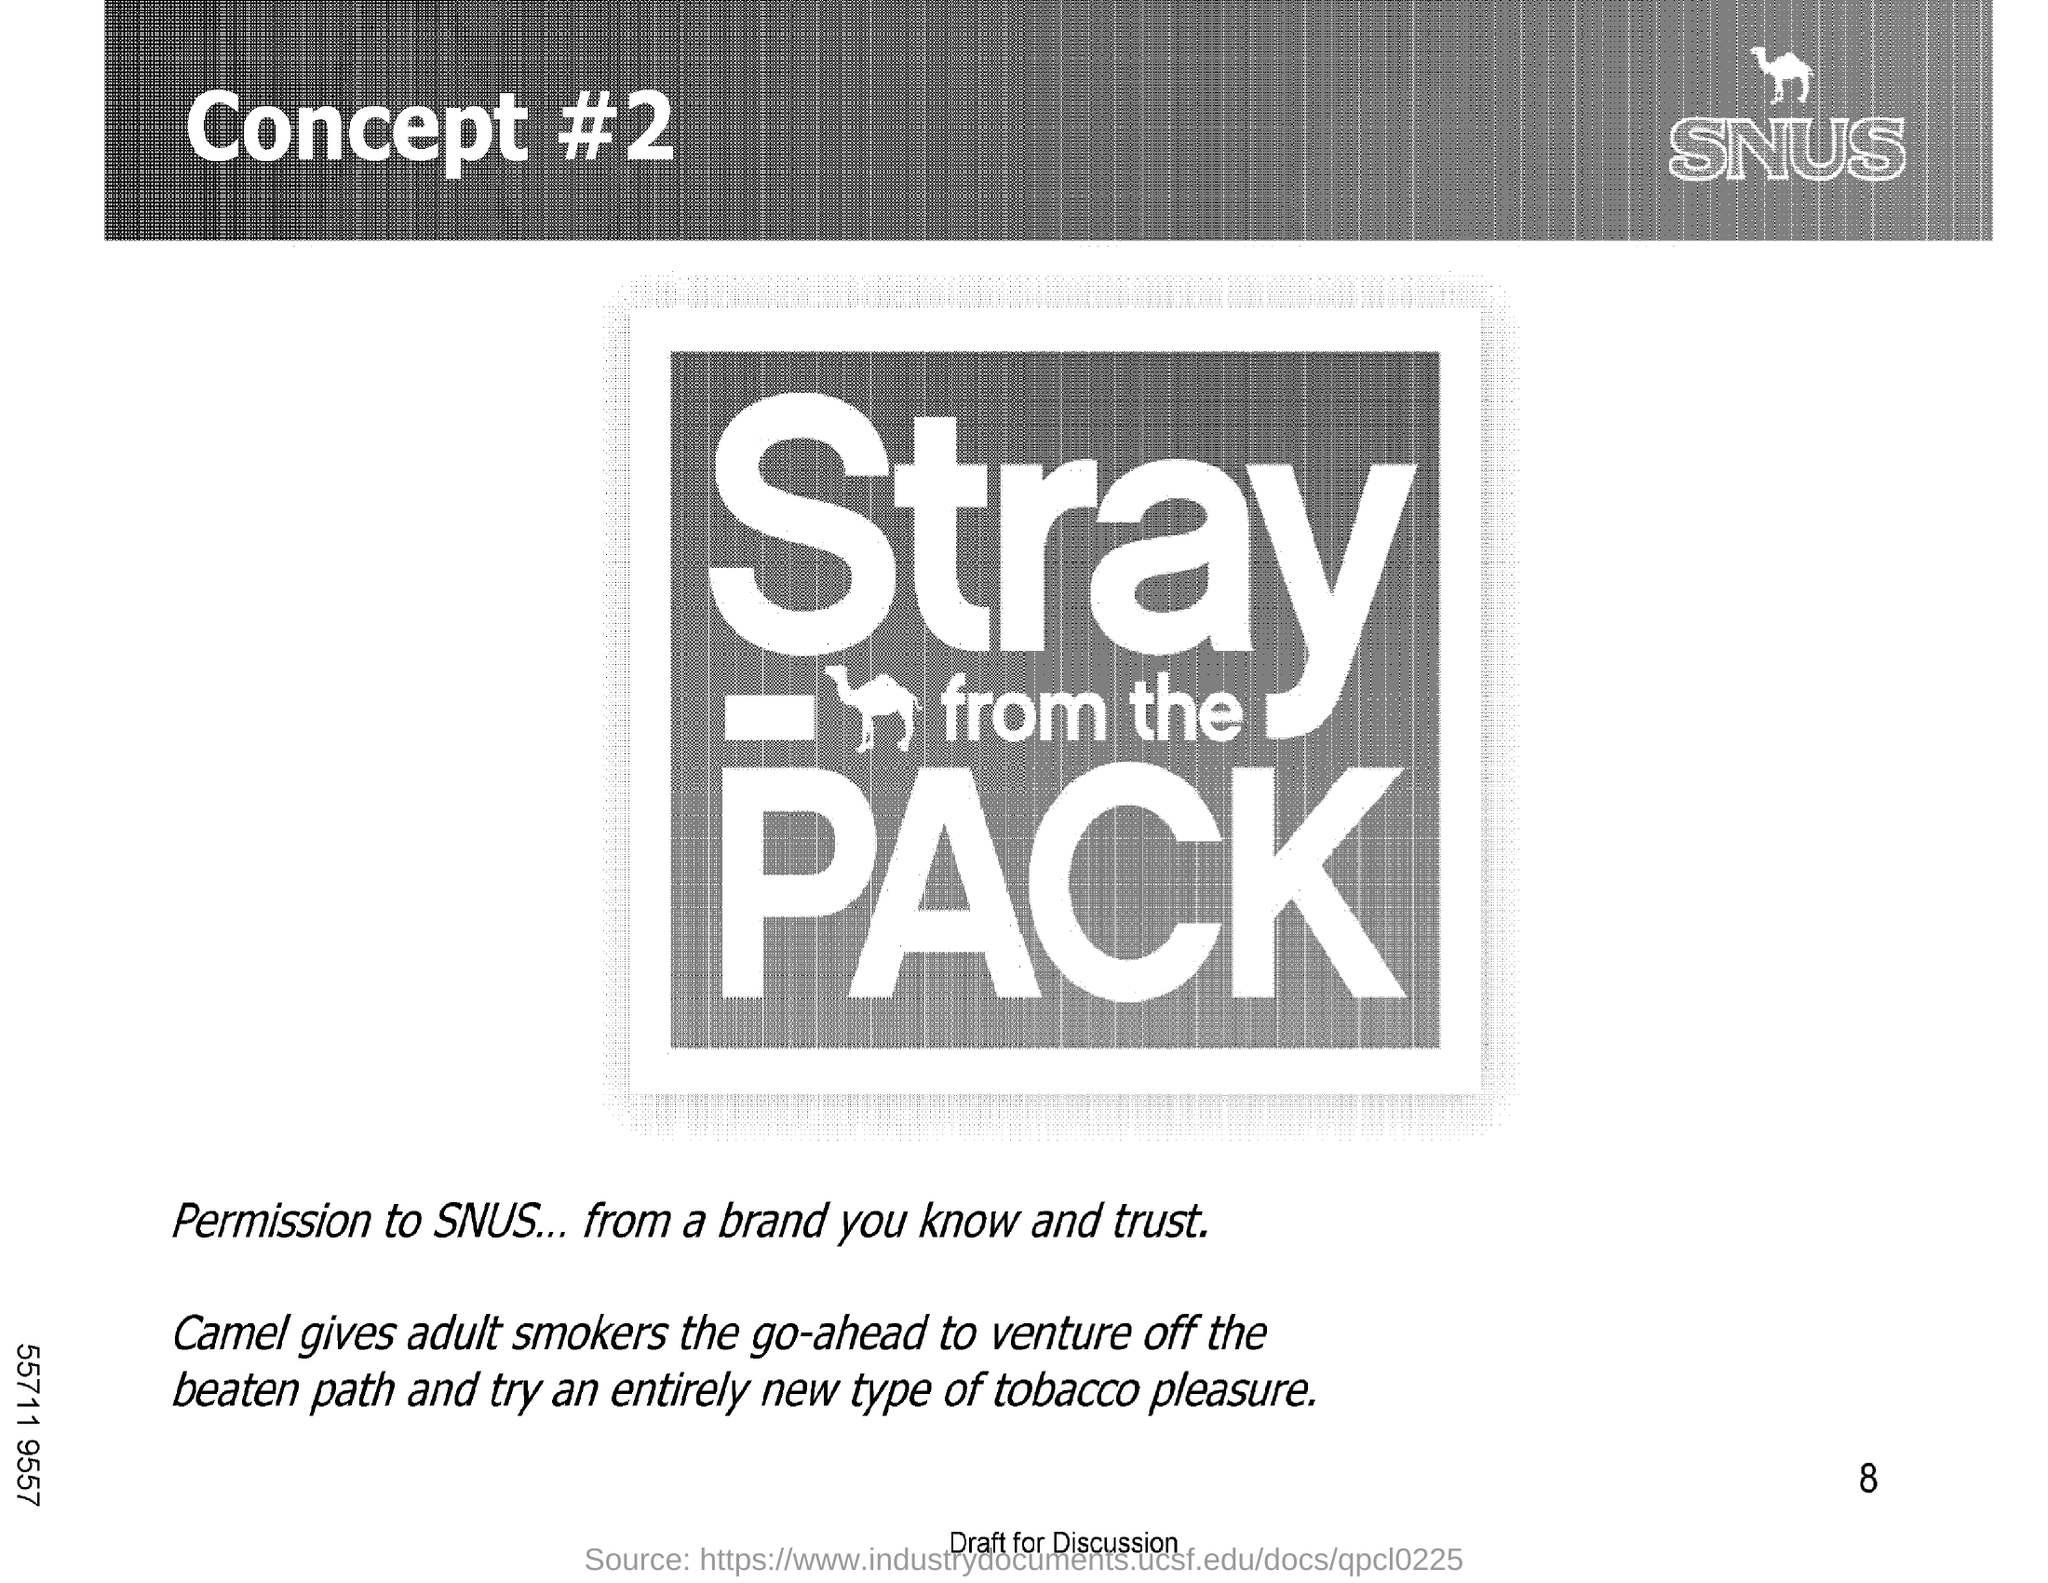What is the heading of the document?
Give a very brief answer. Concept #2. What is written at the top right corner under the logo?
Provide a succinct answer. SNUS. What is written at the bottom of the document above the Source?
Ensure brevity in your answer.  Draft For Discussion. Which animal is mentioned in the document?
Ensure brevity in your answer.  Camel. 